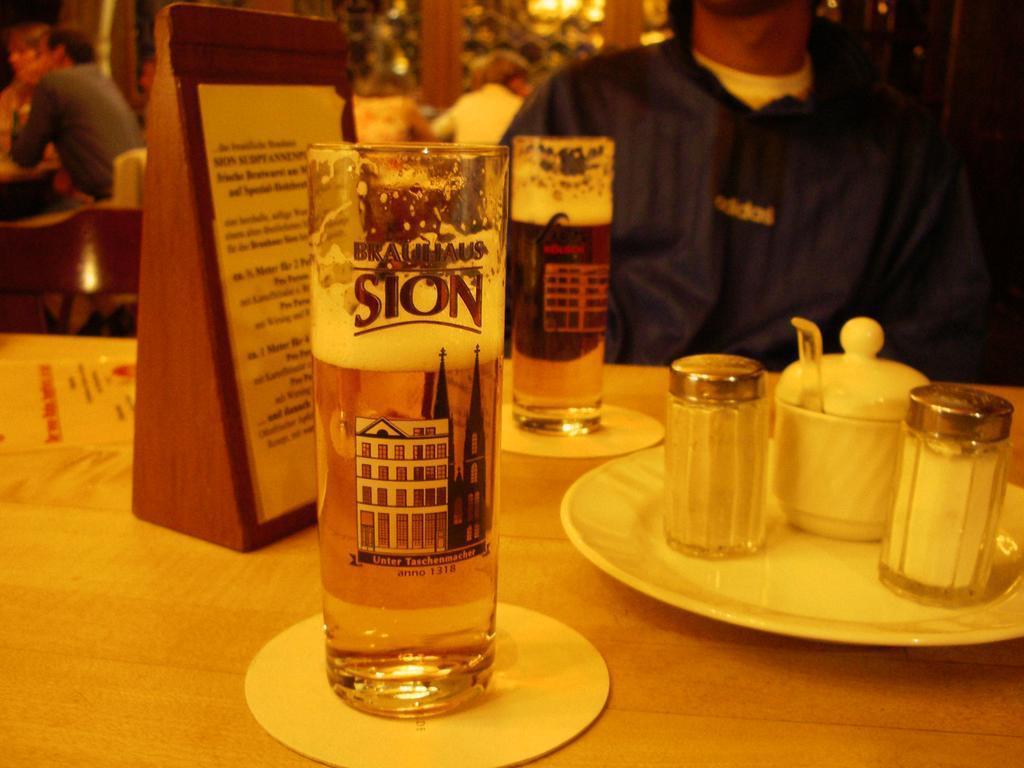What is printed on the glass?
Provide a short and direct response. Brauhaus sion. 